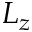<formula> <loc_0><loc_0><loc_500><loc_500>L _ { z }</formula> 